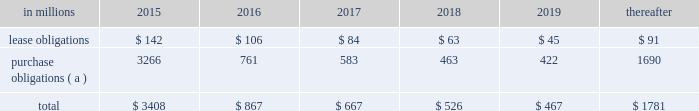At december 31 , 2014 , total future minimum commitments under existing non-cancelable operating leases and purchase obligations were as follows: .
( a ) includes $ 2.3 billion relating to fiber supply agreements entered into at the time of the company 2019s 2006 transformation plan forestland sales and in conjunction with the 2008 acquisition of weyerhaeuser company 2019s containerboard , packaging and recycling business .
Rent expense was $ 154 million , $ 168 million and $ 185 million for 2014 , 2013 and 2012 , respectively .
Guarantees in connection with sales of businesses , property , equipment , forestlands and other assets , international paper commonly makes representations and warranties relating to such businesses or assets , and may agree to indemnify buyers with respect to tax and environmental liabilities , breaches of representations and warranties , and other matters .
Where liabilities for such matters are determined to be probable and subject to reasonable estimation , accrued liabilities are recorded at the time of sale as a cost of the transaction .
Environmental proceedings cercla and state actions international paper has been named as a potentially responsible party in environmental remediation actions under various federal and state laws , including the comprehensive environmental response , compensation and liability act ( cercla ) .
Many of these proceedings involve the cleanup of hazardous substances at large commercial landfills that received waste from many different sources .
While joint and several liability is authorized under cercla and equivalent state laws , as a practical matter , liability for cercla cleanups is typically allocated among the many potential responsible parties .
Remedial costs are recorded in the consolidated financial statements when they become probable and reasonably estimable .
International paper has estimated the probable liability associated with these matters to be approximately $ 95 million in the aggregate as of december 31 , 2014 .
Cass lake : one of the matters referenced above is a closed wood treating facility located in cass lake , minnesota .
During 2009 , in connection with an environmental site remediation action under cercla , international paper submitted to the epa a remediation feasibility study .
In june 2011 , the epa selected and published a proposed soil remedy at the site with an estimated cost of $ 46 million .
The overall remediation reserve for the site is currently $ 50 million to address the selection of an alternative for the soil remediation component of the overall site remedy .
In october 2011 , the epa released a public statement indicating that the final soil remedy decision would be delayed .
In the unlikely event that the epa changes its proposed soil remedy and approves instead a more expensive clean- up alternative , the remediation costs could be material , and significantly higher than amounts currently recorded .
In october 2012 , the natural resource trustees for this site provided notice to international paper and other potentially responsible parties of their intent to perform a natural resource damage assessment .
It is premature to predict the outcome of the assessment or to estimate a loss or range of loss , if any , which may be incurred .
Other remediation costs in addition to the above matters , other remediation costs typically associated with the cleanup of hazardous substances at the company 2019s current , closed or formerly-owned facilities , and recorded as liabilities in the balance sheet , totaled approximately $ 41 million as of december 31 , 2014 .
Other than as described above , completion of required remedial actions is not expected to have a material effect on our consolidated financial statements .
Legal proceedings environmental kalamazoo river : the company is a potentially responsible party with respect to the allied paper , inc./ portage creek/kalamazoo river superfund site ( kalamazoo river superfund site ) in michigan .
The epa asserts that the site is contaminated primarily by pcbs as a result of discharges from various paper mills located along the kalamazoo river , including a paper mill formerly owned by st .
Regis paper company ( st .
Regis ) .
The company is a successor in interest to st .
Regis .
Although the company has not received any orders from the epa , in december 2014 , the epa sent the company a letter demanding payment of $ 19 million to reimburse the epa for costs associated with a time critical removal action of pcb contaminated sediments from a portion of the site .
The company 2019s cercla liability has not been finally determined with respect to this or any other portion of the site and we have declined to reimburse the epa at this time .
As noted below , the company is involved in allocation/ apportionment litigation with regard to the site .
Accordingly , it is premature to estimate a loss or range of loss with respect to this site .
The company was named as a defendant by georgia- pacific consumer products lp , fort james corporation and georgia pacific llc in a contribution and cost recovery action for alleged pollution at the site .
The suit .
What was the cumulative rent expanse from 2012 to 2014? 
Computations: (185 + (154 + 168))
Answer: 507.0. 